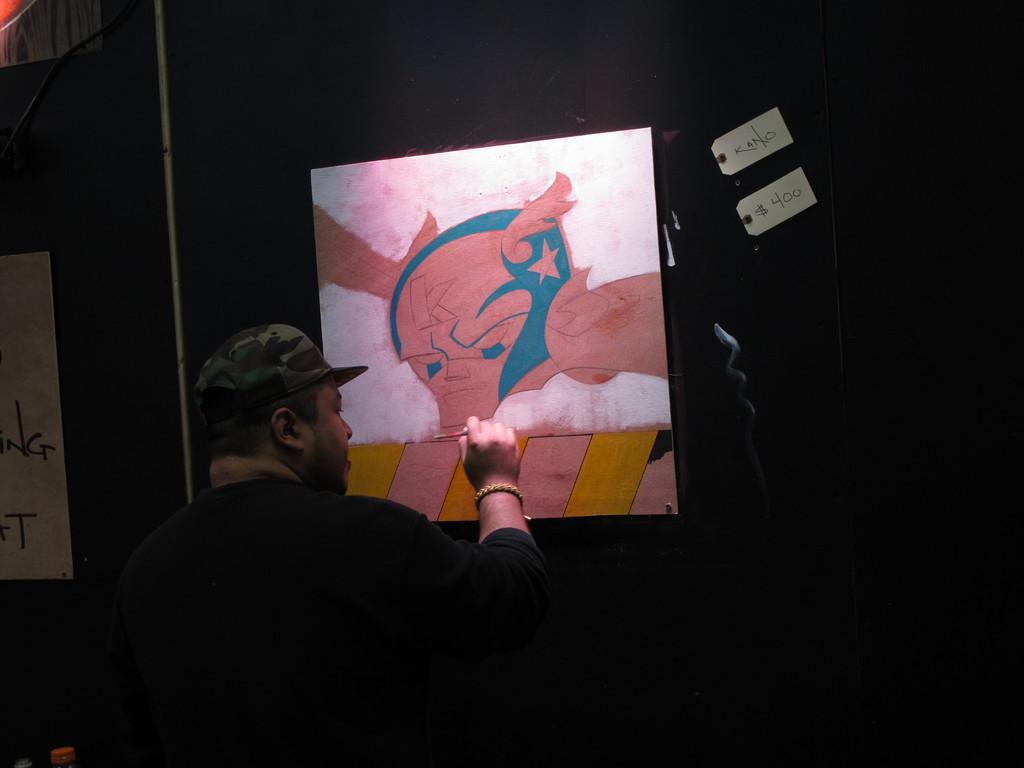How would you summarize this image in a sentence or two? In this picture there is a man on the left side of the image and there is a poster in front of him, it seems to be he is painting and there is another poster on the left side of the image. 